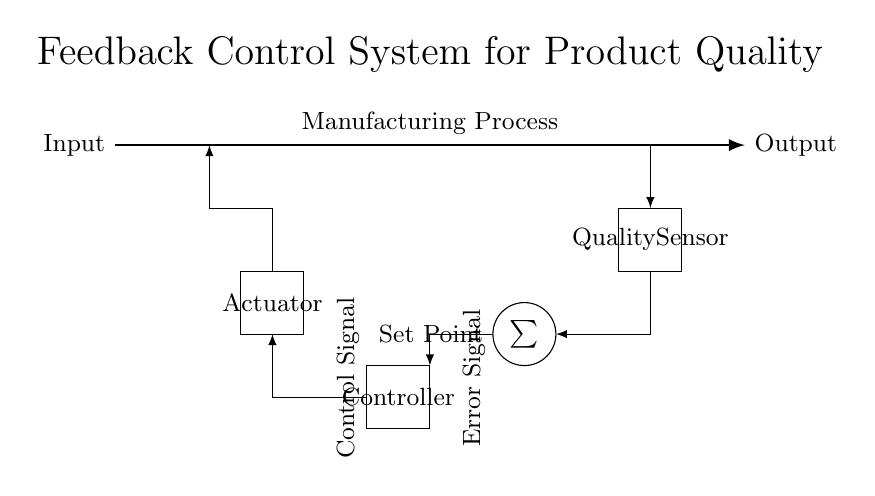What component senses the quality in the manufacturing process? The quality sensor is responsible for detecting the product quality in the process. It is represented by a rectangle labeled "Quality Sensor" in the diagram.
Answer: Quality Sensor What is the function of the summation symbol in the circuit? The summation symbol, depicted in a circular shape, represents the comparator that calculates the error by comparing the set point and the actual quality sensed.
Answer: Comparator How does the actuator respond to the control signal? The actuator, represented as a rectangle in the diagram, receives the control signal and acts accordingly to adjust the manufacturing process, thereby influencing the quality.
Answer: Adjusts Process What does the feedback loop indicate in the control system? The feedback loop shows how the output is monitored and fed back to the input through the quality sensor, serving to regulate the system based on product quality.
Answer: Regulates System What is the role of the controller in the circuit? The controller, depicted as a rectangle, processes the error signal from the comparator and generates the appropriate control signal to the actuator to maintain quality.
Answer: Generates Control Signal How is the error signal created in the feedback control system? The error signal is generated by the comparator, which subtracts the actual quality value from the desired set point, leading to a signal that indicates how far off the output is from the target.
Answer: Difference of Values What does the term "set point" refer to in this diagram? The set point is the desired quality level that the manufacturing process aims to achieve, as indicated by the label next to the summation symbol.
Answer: Desired Quality Level 